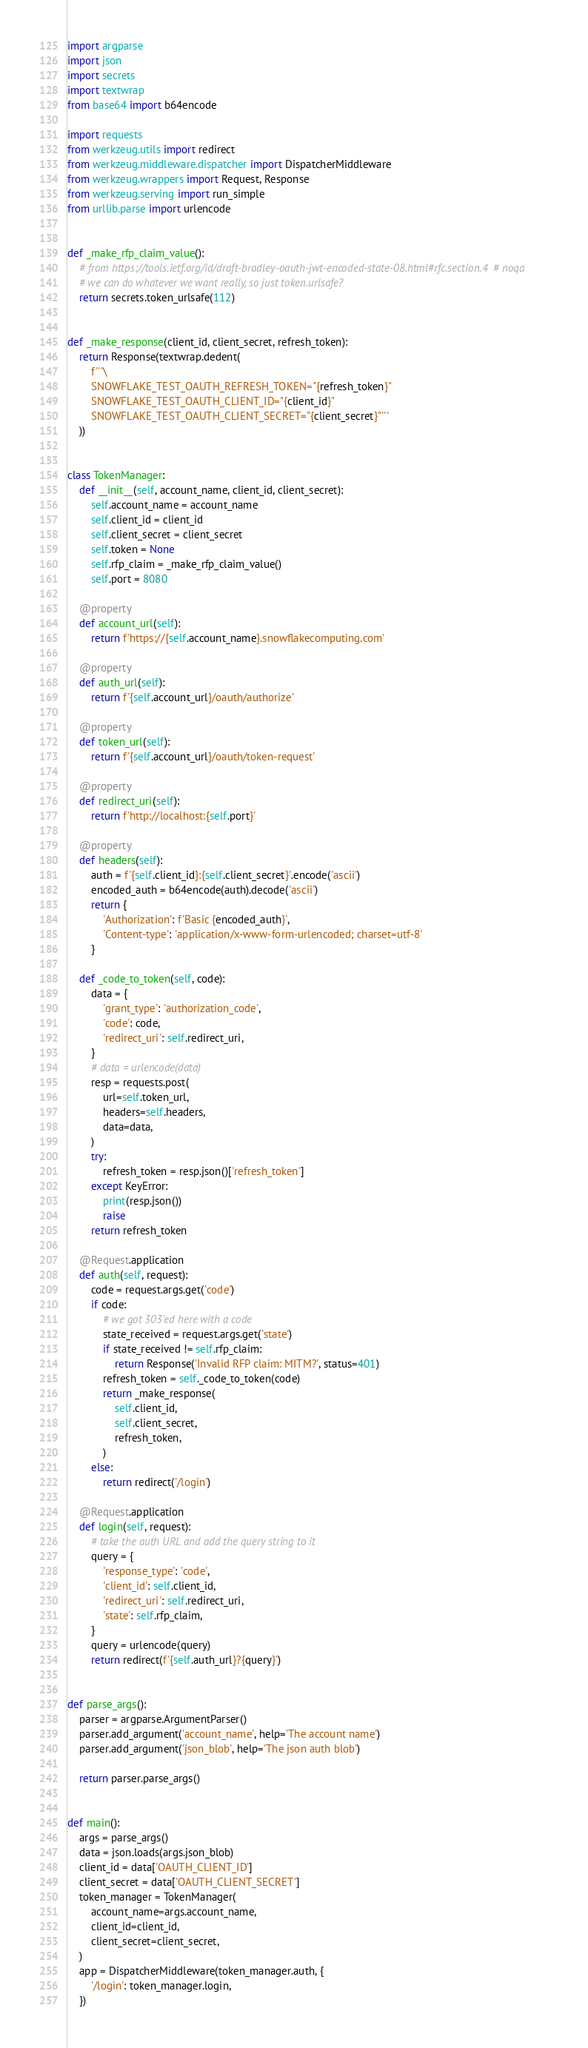Convert code to text. <code><loc_0><loc_0><loc_500><loc_500><_Python_>import argparse
import json
import secrets
import textwrap
from base64 import b64encode

import requests
from werkzeug.utils import redirect
from werkzeug.middleware.dispatcher import DispatcherMiddleware
from werkzeug.wrappers import Request, Response
from werkzeug.serving import run_simple
from urllib.parse import urlencode


def _make_rfp_claim_value():
    # from https://tools.ietf.org/id/draft-bradley-oauth-jwt-encoded-state-08.html#rfc.section.4  # noqa
    # we can do whatever we want really, so just token.urlsafe?
    return secrets.token_urlsafe(112)


def _make_response(client_id, client_secret, refresh_token):
    return Response(textwrap.dedent(
        f'''\
        SNOWFLAKE_TEST_OAUTH_REFRESH_TOKEN="{refresh_token}"
        SNOWFLAKE_TEST_OAUTH_CLIENT_ID="{client_id}"
        SNOWFLAKE_TEST_OAUTH_CLIENT_SECRET="{client_secret}"'''
    ))


class TokenManager:
    def __init__(self, account_name, client_id, client_secret):
        self.account_name = account_name
        self.client_id = client_id
        self.client_secret = client_secret
        self.token = None
        self.rfp_claim = _make_rfp_claim_value()
        self.port = 8080

    @property
    def account_url(self):
        return f'https://{self.account_name}.snowflakecomputing.com'

    @property
    def auth_url(self):
        return f'{self.account_url}/oauth/authorize'

    @property
    def token_url(self):
        return f'{self.account_url}/oauth/token-request'

    @property
    def redirect_uri(self):
        return f'http://localhost:{self.port}'

    @property
    def headers(self):
        auth = f'{self.client_id}:{self.client_secret}'.encode('ascii')
        encoded_auth = b64encode(auth).decode('ascii')
        return {
            'Authorization': f'Basic {encoded_auth}',
            'Content-type': 'application/x-www-form-urlencoded; charset=utf-8'
        }

    def _code_to_token(self, code):
        data = {
            'grant_type': 'authorization_code',
            'code': code,
            'redirect_uri': self.redirect_uri,
        }
        # data = urlencode(data)
        resp = requests.post(
            url=self.token_url,
            headers=self.headers,
            data=data,
        )
        try:
            refresh_token = resp.json()['refresh_token']
        except KeyError:
            print(resp.json())
            raise
        return refresh_token

    @Request.application
    def auth(self, request):
        code = request.args.get('code')
        if code:
            # we got 303'ed here with a code
            state_received = request.args.get('state')
            if state_received != self.rfp_claim:
                return Response('Invalid RFP claim: MITM?', status=401)
            refresh_token = self._code_to_token(code)
            return _make_response(
                self.client_id,
                self.client_secret,
                refresh_token,
            )
        else:
            return redirect('/login')

    @Request.application
    def login(self, request):
        # take the auth URL and add the query string to it
        query = {
            'response_type': 'code',
            'client_id': self.client_id,
            'redirect_uri': self.redirect_uri,
            'state': self.rfp_claim,
        }
        query = urlencode(query)
        return redirect(f'{self.auth_url}?{query}')


def parse_args():
    parser = argparse.ArgumentParser()
    parser.add_argument('account_name', help='The account name')
    parser.add_argument('json_blob', help='The json auth blob')

    return parser.parse_args()


def main():
    args = parse_args()
    data = json.loads(args.json_blob)
    client_id = data['OAUTH_CLIENT_ID']
    client_secret = data['OAUTH_CLIENT_SECRET']
    token_manager = TokenManager(
        account_name=args.account_name,
        client_id=client_id,
        client_secret=client_secret,
    )
    app = DispatcherMiddleware(token_manager.auth, {
        '/login': token_manager.login,
    })
</code> 